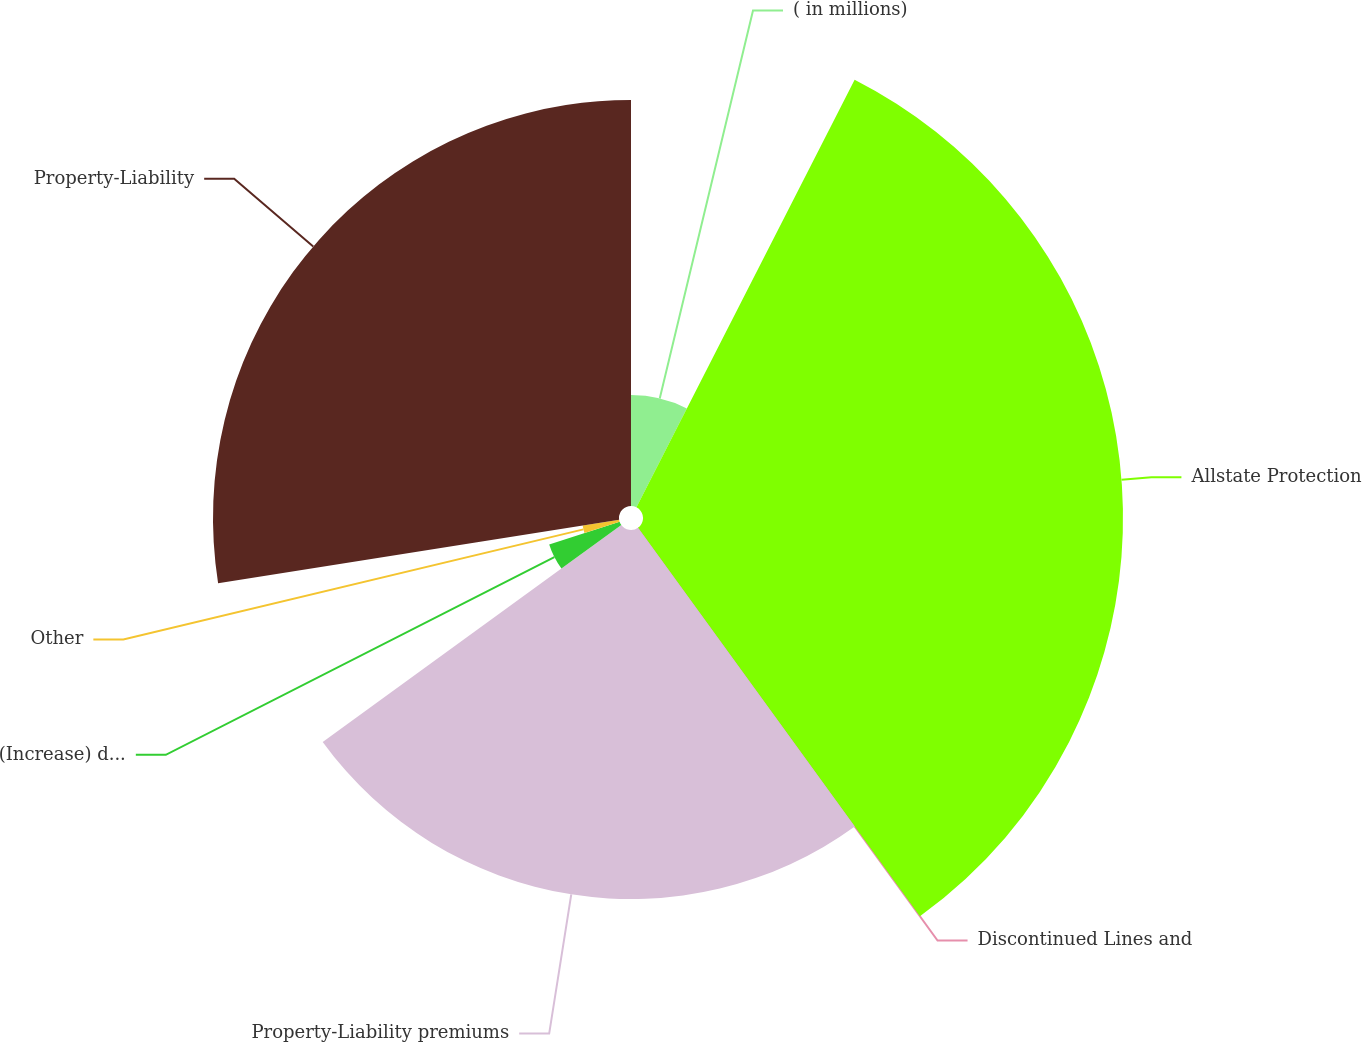Convert chart to OTSL. <chart><loc_0><loc_0><loc_500><loc_500><pie_chart><fcel>( in millions)<fcel>Allstate Protection<fcel>Discontinued Lines and<fcel>Property-Liability premiums<fcel>(Increase) decrease in<fcel>Other<fcel>Property-Liability<nl><fcel>7.51%<fcel>32.5%<fcel>0.0%<fcel>24.99%<fcel>5.01%<fcel>2.5%<fcel>27.49%<nl></chart> 